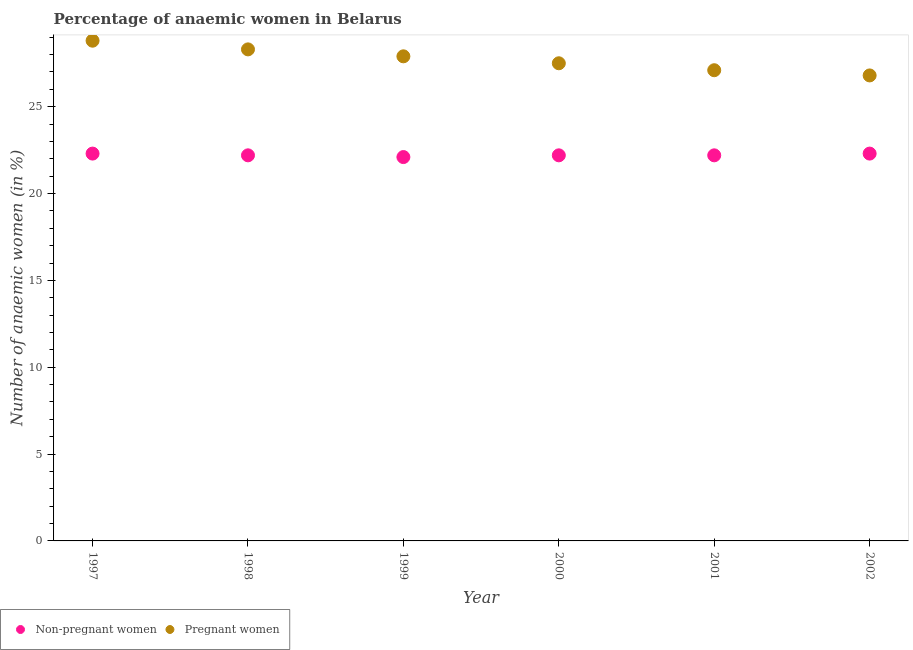How many different coloured dotlines are there?
Ensure brevity in your answer.  2. What is the percentage of non-pregnant anaemic women in 2000?
Offer a terse response. 22.2. Across all years, what is the maximum percentage of pregnant anaemic women?
Make the answer very short. 28.8. Across all years, what is the minimum percentage of pregnant anaemic women?
Your response must be concise. 26.8. What is the total percentage of pregnant anaemic women in the graph?
Offer a terse response. 166.4. What is the difference between the percentage of non-pregnant anaemic women in 1999 and that in 2000?
Ensure brevity in your answer.  -0.1. What is the difference between the percentage of pregnant anaemic women in 1999 and the percentage of non-pregnant anaemic women in 2000?
Provide a short and direct response. 5.7. What is the average percentage of non-pregnant anaemic women per year?
Your response must be concise. 22.22. In the year 2001, what is the difference between the percentage of pregnant anaemic women and percentage of non-pregnant anaemic women?
Offer a very short reply. 4.9. In how many years, is the percentage of non-pregnant anaemic women greater than 5 %?
Provide a short and direct response. 6. What is the ratio of the percentage of non-pregnant anaemic women in 1998 to that in 2002?
Give a very brief answer. 1. Is the percentage of non-pregnant anaemic women in 1997 less than that in 1999?
Provide a succinct answer. No. Is the difference between the percentage of pregnant anaemic women in 2000 and 2001 greater than the difference between the percentage of non-pregnant anaemic women in 2000 and 2001?
Your answer should be very brief. Yes. What is the difference between the highest and the lowest percentage of non-pregnant anaemic women?
Give a very brief answer. 0.2. Does the percentage of non-pregnant anaemic women monotonically increase over the years?
Your answer should be compact. No. Is the percentage of non-pregnant anaemic women strictly greater than the percentage of pregnant anaemic women over the years?
Provide a short and direct response. No. How many dotlines are there?
Your answer should be compact. 2. How many years are there in the graph?
Your answer should be compact. 6. What is the difference between two consecutive major ticks on the Y-axis?
Your answer should be very brief. 5. Does the graph contain any zero values?
Offer a very short reply. No. Where does the legend appear in the graph?
Give a very brief answer. Bottom left. How many legend labels are there?
Offer a very short reply. 2. How are the legend labels stacked?
Provide a short and direct response. Horizontal. What is the title of the graph?
Offer a terse response. Percentage of anaemic women in Belarus. Does "Formally registered" appear as one of the legend labels in the graph?
Provide a succinct answer. No. What is the label or title of the Y-axis?
Give a very brief answer. Number of anaemic women (in %). What is the Number of anaemic women (in %) of Non-pregnant women in 1997?
Your answer should be very brief. 22.3. What is the Number of anaemic women (in %) in Pregnant women in 1997?
Provide a succinct answer. 28.8. What is the Number of anaemic women (in %) of Non-pregnant women in 1998?
Provide a succinct answer. 22.2. What is the Number of anaemic women (in %) of Pregnant women in 1998?
Make the answer very short. 28.3. What is the Number of anaemic women (in %) of Non-pregnant women in 1999?
Your answer should be compact. 22.1. What is the Number of anaemic women (in %) of Pregnant women in 1999?
Give a very brief answer. 27.9. What is the Number of anaemic women (in %) of Pregnant women in 2000?
Provide a short and direct response. 27.5. What is the Number of anaemic women (in %) of Non-pregnant women in 2001?
Keep it short and to the point. 22.2. What is the Number of anaemic women (in %) in Pregnant women in 2001?
Offer a terse response. 27.1. What is the Number of anaemic women (in %) of Non-pregnant women in 2002?
Keep it short and to the point. 22.3. What is the Number of anaemic women (in %) in Pregnant women in 2002?
Your answer should be very brief. 26.8. Across all years, what is the maximum Number of anaemic women (in %) in Non-pregnant women?
Give a very brief answer. 22.3. Across all years, what is the maximum Number of anaemic women (in %) of Pregnant women?
Provide a short and direct response. 28.8. Across all years, what is the minimum Number of anaemic women (in %) of Non-pregnant women?
Your answer should be very brief. 22.1. Across all years, what is the minimum Number of anaemic women (in %) in Pregnant women?
Your answer should be compact. 26.8. What is the total Number of anaemic women (in %) of Non-pregnant women in the graph?
Your response must be concise. 133.3. What is the total Number of anaemic women (in %) in Pregnant women in the graph?
Your response must be concise. 166.4. What is the difference between the Number of anaemic women (in %) of Pregnant women in 1997 and that in 1998?
Make the answer very short. 0.5. What is the difference between the Number of anaemic women (in %) of Non-pregnant women in 1997 and that in 1999?
Give a very brief answer. 0.2. What is the difference between the Number of anaemic women (in %) of Pregnant women in 1997 and that in 1999?
Your answer should be very brief. 0.9. What is the difference between the Number of anaemic women (in %) of Non-pregnant women in 1997 and that in 2000?
Offer a terse response. 0.1. What is the difference between the Number of anaemic women (in %) in Pregnant women in 1997 and that in 2002?
Your response must be concise. 2. What is the difference between the Number of anaemic women (in %) in Pregnant women in 1998 and that in 1999?
Your answer should be very brief. 0.4. What is the difference between the Number of anaemic women (in %) in Non-pregnant women in 1998 and that in 2000?
Your answer should be compact. 0. What is the difference between the Number of anaemic women (in %) in Pregnant women in 1998 and that in 2000?
Offer a terse response. 0.8. What is the difference between the Number of anaemic women (in %) of Pregnant women in 1998 and that in 2001?
Offer a very short reply. 1.2. What is the difference between the Number of anaemic women (in %) of Non-pregnant women in 1998 and that in 2002?
Ensure brevity in your answer.  -0.1. What is the difference between the Number of anaemic women (in %) in Non-pregnant women in 1999 and that in 2000?
Your response must be concise. -0.1. What is the difference between the Number of anaemic women (in %) in Pregnant women in 1999 and that in 2000?
Make the answer very short. 0.4. What is the difference between the Number of anaemic women (in %) of Non-pregnant women in 1999 and that in 2001?
Make the answer very short. -0.1. What is the difference between the Number of anaemic women (in %) in Pregnant women in 1999 and that in 2002?
Offer a terse response. 1.1. What is the difference between the Number of anaemic women (in %) of Pregnant women in 2000 and that in 2001?
Your answer should be compact. 0.4. What is the difference between the Number of anaemic women (in %) in Non-pregnant women in 2001 and that in 2002?
Offer a very short reply. -0.1. What is the difference between the Number of anaemic women (in %) in Non-pregnant women in 1997 and the Number of anaemic women (in %) in Pregnant women in 2000?
Keep it short and to the point. -5.2. What is the difference between the Number of anaemic women (in %) of Non-pregnant women in 1997 and the Number of anaemic women (in %) of Pregnant women in 2001?
Your answer should be very brief. -4.8. What is the difference between the Number of anaemic women (in %) in Non-pregnant women in 1997 and the Number of anaemic women (in %) in Pregnant women in 2002?
Your response must be concise. -4.5. What is the difference between the Number of anaemic women (in %) in Non-pregnant women in 1998 and the Number of anaemic women (in %) in Pregnant women in 2000?
Offer a terse response. -5.3. What is the difference between the Number of anaemic women (in %) in Non-pregnant women in 1998 and the Number of anaemic women (in %) in Pregnant women in 2001?
Provide a succinct answer. -4.9. What is the difference between the Number of anaemic women (in %) in Non-pregnant women in 1999 and the Number of anaemic women (in %) in Pregnant women in 2001?
Provide a short and direct response. -5. What is the difference between the Number of anaemic women (in %) in Non-pregnant women in 1999 and the Number of anaemic women (in %) in Pregnant women in 2002?
Offer a very short reply. -4.7. What is the difference between the Number of anaemic women (in %) in Non-pregnant women in 2000 and the Number of anaemic women (in %) in Pregnant women in 2002?
Keep it short and to the point. -4.6. What is the average Number of anaemic women (in %) in Non-pregnant women per year?
Offer a terse response. 22.22. What is the average Number of anaemic women (in %) in Pregnant women per year?
Offer a terse response. 27.73. In the year 1997, what is the difference between the Number of anaemic women (in %) of Non-pregnant women and Number of anaemic women (in %) of Pregnant women?
Provide a short and direct response. -6.5. In the year 1998, what is the difference between the Number of anaemic women (in %) in Non-pregnant women and Number of anaemic women (in %) in Pregnant women?
Offer a terse response. -6.1. In the year 2000, what is the difference between the Number of anaemic women (in %) in Non-pregnant women and Number of anaemic women (in %) in Pregnant women?
Give a very brief answer. -5.3. In the year 2002, what is the difference between the Number of anaemic women (in %) in Non-pregnant women and Number of anaemic women (in %) in Pregnant women?
Offer a terse response. -4.5. What is the ratio of the Number of anaemic women (in %) of Non-pregnant women in 1997 to that in 1998?
Your answer should be very brief. 1. What is the ratio of the Number of anaemic women (in %) in Pregnant women in 1997 to that in 1998?
Offer a terse response. 1.02. What is the ratio of the Number of anaemic women (in %) of Pregnant women in 1997 to that in 1999?
Your answer should be very brief. 1.03. What is the ratio of the Number of anaemic women (in %) of Pregnant women in 1997 to that in 2000?
Make the answer very short. 1.05. What is the ratio of the Number of anaemic women (in %) of Non-pregnant women in 1997 to that in 2001?
Give a very brief answer. 1. What is the ratio of the Number of anaemic women (in %) in Pregnant women in 1997 to that in 2001?
Your response must be concise. 1.06. What is the ratio of the Number of anaemic women (in %) in Pregnant women in 1997 to that in 2002?
Provide a short and direct response. 1.07. What is the ratio of the Number of anaemic women (in %) of Pregnant women in 1998 to that in 1999?
Offer a terse response. 1.01. What is the ratio of the Number of anaemic women (in %) in Non-pregnant women in 1998 to that in 2000?
Keep it short and to the point. 1. What is the ratio of the Number of anaemic women (in %) in Pregnant women in 1998 to that in 2000?
Your response must be concise. 1.03. What is the ratio of the Number of anaemic women (in %) of Pregnant women in 1998 to that in 2001?
Offer a terse response. 1.04. What is the ratio of the Number of anaemic women (in %) of Pregnant women in 1998 to that in 2002?
Offer a terse response. 1.06. What is the ratio of the Number of anaemic women (in %) of Non-pregnant women in 1999 to that in 2000?
Your answer should be compact. 1. What is the ratio of the Number of anaemic women (in %) in Pregnant women in 1999 to that in 2000?
Your response must be concise. 1.01. What is the ratio of the Number of anaemic women (in %) of Pregnant women in 1999 to that in 2001?
Provide a succinct answer. 1.03. What is the ratio of the Number of anaemic women (in %) of Non-pregnant women in 1999 to that in 2002?
Offer a very short reply. 0.99. What is the ratio of the Number of anaemic women (in %) of Pregnant women in 1999 to that in 2002?
Your answer should be compact. 1.04. What is the ratio of the Number of anaemic women (in %) of Pregnant women in 2000 to that in 2001?
Give a very brief answer. 1.01. What is the ratio of the Number of anaemic women (in %) in Pregnant women in 2000 to that in 2002?
Your answer should be very brief. 1.03. What is the ratio of the Number of anaemic women (in %) in Non-pregnant women in 2001 to that in 2002?
Offer a terse response. 1. What is the ratio of the Number of anaemic women (in %) in Pregnant women in 2001 to that in 2002?
Provide a succinct answer. 1.01. What is the difference between the highest and the second highest Number of anaemic women (in %) in Pregnant women?
Provide a short and direct response. 0.5. What is the difference between the highest and the lowest Number of anaemic women (in %) in Non-pregnant women?
Offer a terse response. 0.2. 